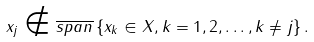<formula> <loc_0><loc_0><loc_500><loc_500>x _ { j } \notin \overline { s p a n } \left \{ x _ { k } \in X , k = 1 , 2 , \dots , k \neq j \right \} .</formula> 